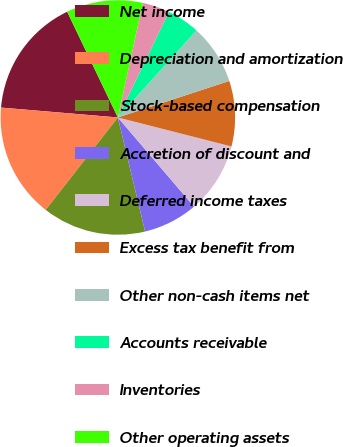<chart> <loc_0><loc_0><loc_500><loc_500><pie_chart><fcel>Net income<fcel>Depreciation and amortization<fcel>Stock-based compensation<fcel>Accretion of discount and<fcel>Deferred income taxes<fcel>Excess tax benefit from<fcel>Other non-cash items net<fcel>Accounts receivable<fcel>Inventories<fcel>Other operating assets<nl><fcel>16.54%<fcel>15.79%<fcel>14.28%<fcel>7.52%<fcel>9.77%<fcel>9.02%<fcel>8.27%<fcel>4.51%<fcel>3.76%<fcel>10.53%<nl></chart> 